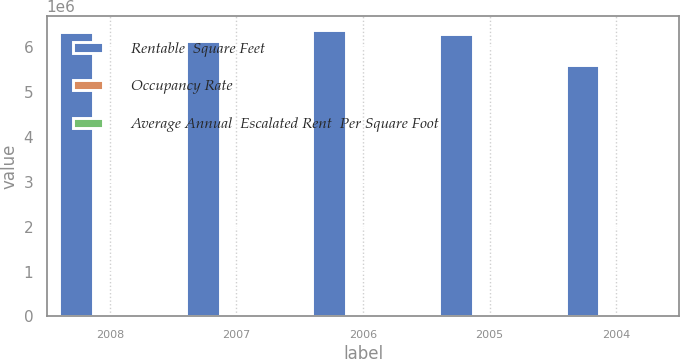Convert chart to OTSL. <chart><loc_0><loc_0><loc_500><loc_500><stacked_bar_chart><ecel><fcel>2008<fcel>2007<fcel>2006<fcel>2005<fcel>2004<nl><fcel>Rentable  Square Feet<fcel>6.332e+06<fcel>6.139e+06<fcel>6.37e+06<fcel>6.29e+06<fcel>5.589e+06<nl><fcel>Occupancy Rate<fcel>92.2<fcel>93.7<fcel>93.6<fcel>94.7<fcel>97.6<nl><fcel>Average Annual  Escalated Rent  Per Square Foot<fcel>26.72<fcel>26.16<fcel>25.17<fcel>24.04<fcel>23.08<nl></chart> 